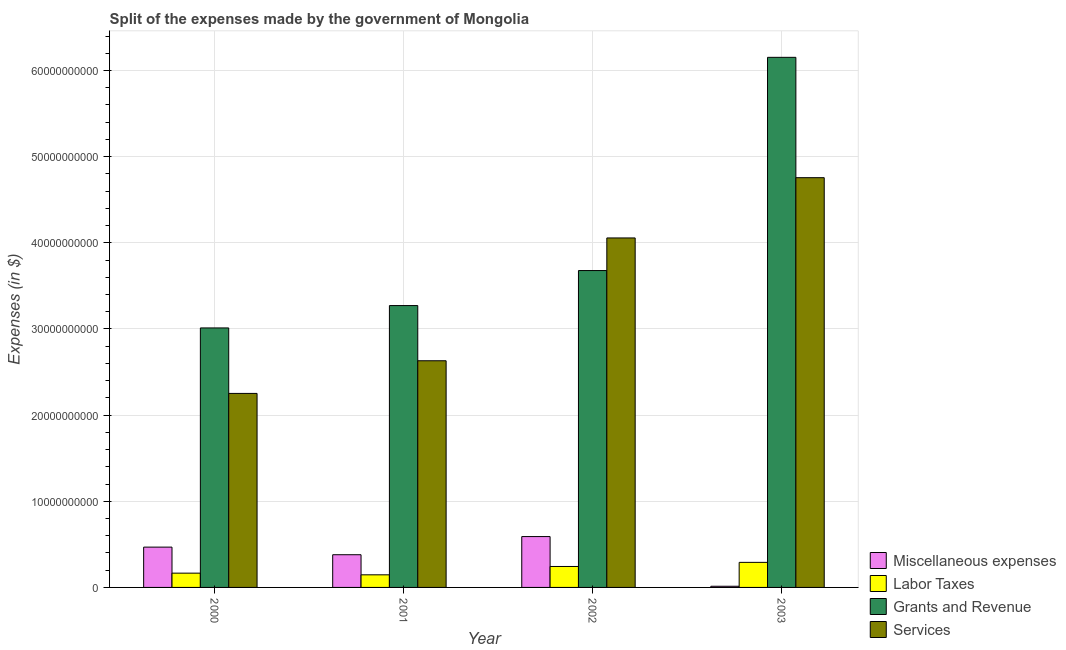How many groups of bars are there?
Your answer should be compact. 4. Are the number of bars per tick equal to the number of legend labels?
Offer a very short reply. Yes. Are the number of bars on each tick of the X-axis equal?
Ensure brevity in your answer.  Yes. What is the label of the 3rd group of bars from the left?
Make the answer very short. 2002. What is the amount spent on labor taxes in 2000?
Your response must be concise. 1.66e+09. Across all years, what is the maximum amount spent on services?
Give a very brief answer. 4.76e+1. Across all years, what is the minimum amount spent on grants and revenue?
Ensure brevity in your answer.  3.01e+1. What is the total amount spent on labor taxes in the graph?
Ensure brevity in your answer.  8.46e+09. What is the difference between the amount spent on miscellaneous expenses in 2000 and that in 2001?
Your response must be concise. 8.82e+08. What is the difference between the amount spent on grants and revenue in 2003 and the amount spent on miscellaneous expenses in 2001?
Offer a terse response. 2.88e+1. What is the average amount spent on grants and revenue per year?
Your answer should be compact. 4.03e+1. What is the ratio of the amount spent on services in 2001 to that in 2003?
Your answer should be compact. 0.55. Is the amount spent on miscellaneous expenses in 2001 less than that in 2002?
Your response must be concise. Yes. Is the difference between the amount spent on labor taxes in 2000 and 2001 greater than the difference between the amount spent on grants and revenue in 2000 and 2001?
Your answer should be very brief. No. What is the difference between the highest and the second highest amount spent on miscellaneous expenses?
Offer a very short reply. 1.22e+09. What is the difference between the highest and the lowest amount spent on miscellaneous expenses?
Offer a very short reply. 5.77e+09. Is the sum of the amount spent on grants and revenue in 2001 and 2003 greater than the maximum amount spent on miscellaneous expenses across all years?
Your response must be concise. Yes. What does the 2nd bar from the left in 2000 represents?
Provide a succinct answer. Labor Taxes. What does the 4th bar from the right in 2002 represents?
Your answer should be compact. Miscellaneous expenses. How many years are there in the graph?
Give a very brief answer. 4. What is the difference between two consecutive major ticks on the Y-axis?
Give a very brief answer. 1.00e+1. Are the values on the major ticks of Y-axis written in scientific E-notation?
Your answer should be very brief. No. Does the graph contain any zero values?
Your answer should be compact. No. Where does the legend appear in the graph?
Your response must be concise. Bottom right. How are the legend labels stacked?
Ensure brevity in your answer.  Vertical. What is the title of the graph?
Your response must be concise. Split of the expenses made by the government of Mongolia. Does "UNDP" appear as one of the legend labels in the graph?
Your answer should be very brief. No. What is the label or title of the X-axis?
Provide a succinct answer. Year. What is the label or title of the Y-axis?
Give a very brief answer. Expenses (in $). What is the Expenses (in $) in Miscellaneous expenses in 2000?
Your response must be concise. 4.68e+09. What is the Expenses (in $) in Labor Taxes in 2000?
Your answer should be compact. 1.66e+09. What is the Expenses (in $) of Grants and Revenue in 2000?
Your answer should be compact. 3.01e+1. What is the Expenses (in $) in Services in 2000?
Provide a short and direct response. 2.25e+1. What is the Expenses (in $) in Miscellaneous expenses in 2001?
Offer a very short reply. 3.80e+09. What is the Expenses (in $) in Labor Taxes in 2001?
Offer a very short reply. 1.46e+09. What is the Expenses (in $) in Grants and Revenue in 2001?
Offer a terse response. 3.27e+1. What is the Expenses (in $) in Services in 2001?
Make the answer very short. 2.63e+1. What is the Expenses (in $) of Miscellaneous expenses in 2002?
Keep it short and to the point. 5.90e+09. What is the Expenses (in $) in Labor Taxes in 2002?
Ensure brevity in your answer.  2.43e+09. What is the Expenses (in $) of Grants and Revenue in 2002?
Your answer should be compact. 3.68e+1. What is the Expenses (in $) of Services in 2002?
Offer a very short reply. 4.06e+1. What is the Expenses (in $) in Miscellaneous expenses in 2003?
Provide a succinct answer. 1.35e+08. What is the Expenses (in $) in Labor Taxes in 2003?
Your response must be concise. 2.91e+09. What is the Expenses (in $) of Grants and Revenue in 2003?
Your response must be concise. 6.15e+1. What is the Expenses (in $) of Services in 2003?
Make the answer very short. 4.76e+1. Across all years, what is the maximum Expenses (in $) in Miscellaneous expenses?
Ensure brevity in your answer.  5.90e+09. Across all years, what is the maximum Expenses (in $) of Labor Taxes?
Offer a very short reply. 2.91e+09. Across all years, what is the maximum Expenses (in $) in Grants and Revenue?
Offer a terse response. 6.15e+1. Across all years, what is the maximum Expenses (in $) of Services?
Provide a short and direct response. 4.76e+1. Across all years, what is the minimum Expenses (in $) of Miscellaneous expenses?
Ensure brevity in your answer.  1.35e+08. Across all years, what is the minimum Expenses (in $) of Labor Taxes?
Provide a succinct answer. 1.46e+09. Across all years, what is the minimum Expenses (in $) in Grants and Revenue?
Your answer should be compact. 3.01e+1. Across all years, what is the minimum Expenses (in $) of Services?
Ensure brevity in your answer.  2.25e+1. What is the total Expenses (in $) in Miscellaneous expenses in the graph?
Your answer should be very brief. 1.45e+1. What is the total Expenses (in $) of Labor Taxes in the graph?
Ensure brevity in your answer.  8.46e+09. What is the total Expenses (in $) of Grants and Revenue in the graph?
Offer a terse response. 1.61e+11. What is the total Expenses (in $) of Services in the graph?
Your answer should be compact. 1.37e+11. What is the difference between the Expenses (in $) in Miscellaneous expenses in 2000 and that in 2001?
Offer a terse response. 8.82e+08. What is the difference between the Expenses (in $) of Labor Taxes in 2000 and that in 2001?
Provide a short and direct response. 1.94e+08. What is the difference between the Expenses (in $) of Grants and Revenue in 2000 and that in 2001?
Keep it short and to the point. -2.60e+09. What is the difference between the Expenses (in $) in Services in 2000 and that in 2001?
Provide a succinct answer. -3.79e+09. What is the difference between the Expenses (in $) in Miscellaneous expenses in 2000 and that in 2002?
Provide a succinct answer. -1.22e+09. What is the difference between the Expenses (in $) of Labor Taxes in 2000 and that in 2002?
Your answer should be very brief. -7.74e+08. What is the difference between the Expenses (in $) in Grants and Revenue in 2000 and that in 2002?
Keep it short and to the point. -6.66e+09. What is the difference between the Expenses (in $) in Services in 2000 and that in 2002?
Give a very brief answer. -1.80e+1. What is the difference between the Expenses (in $) in Miscellaneous expenses in 2000 and that in 2003?
Provide a short and direct response. 4.54e+09. What is the difference between the Expenses (in $) in Labor Taxes in 2000 and that in 2003?
Offer a terse response. -1.25e+09. What is the difference between the Expenses (in $) in Grants and Revenue in 2000 and that in 2003?
Your answer should be compact. -3.14e+1. What is the difference between the Expenses (in $) of Services in 2000 and that in 2003?
Keep it short and to the point. -2.50e+1. What is the difference between the Expenses (in $) of Miscellaneous expenses in 2001 and that in 2002?
Offer a terse response. -2.11e+09. What is the difference between the Expenses (in $) of Labor Taxes in 2001 and that in 2002?
Offer a very short reply. -9.68e+08. What is the difference between the Expenses (in $) of Grants and Revenue in 2001 and that in 2002?
Your answer should be compact. -4.06e+09. What is the difference between the Expenses (in $) in Services in 2001 and that in 2002?
Your answer should be very brief. -1.43e+1. What is the difference between the Expenses (in $) in Miscellaneous expenses in 2001 and that in 2003?
Keep it short and to the point. 3.66e+09. What is the difference between the Expenses (in $) in Labor Taxes in 2001 and that in 2003?
Your answer should be compact. -1.44e+09. What is the difference between the Expenses (in $) in Grants and Revenue in 2001 and that in 2003?
Offer a terse response. -2.88e+1. What is the difference between the Expenses (in $) in Services in 2001 and that in 2003?
Offer a very short reply. -2.12e+1. What is the difference between the Expenses (in $) of Miscellaneous expenses in 2002 and that in 2003?
Offer a terse response. 5.77e+09. What is the difference between the Expenses (in $) in Labor Taxes in 2002 and that in 2003?
Offer a very short reply. -4.76e+08. What is the difference between the Expenses (in $) in Grants and Revenue in 2002 and that in 2003?
Your answer should be compact. -2.47e+1. What is the difference between the Expenses (in $) of Services in 2002 and that in 2003?
Ensure brevity in your answer.  -6.99e+09. What is the difference between the Expenses (in $) of Miscellaneous expenses in 2000 and the Expenses (in $) of Labor Taxes in 2001?
Keep it short and to the point. 3.21e+09. What is the difference between the Expenses (in $) in Miscellaneous expenses in 2000 and the Expenses (in $) in Grants and Revenue in 2001?
Give a very brief answer. -2.80e+1. What is the difference between the Expenses (in $) in Miscellaneous expenses in 2000 and the Expenses (in $) in Services in 2001?
Give a very brief answer. -2.16e+1. What is the difference between the Expenses (in $) of Labor Taxes in 2000 and the Expenses (in $) of Grants and Revenue in 2001?
Offer a terse response. -3.11e+1. What is the difference between the Expenses (in $) in Labor Taxes in 2000 and the Expenses (in $) in Services in 2001?
Ensure brevity in your answer.  -2.47e+1. What is the difference between the Expenses (in $) of Grants and Revenue in 2000 and the Expenses (in $) of Services in 2001?
Your answer should be compact. 3.81e+09. What is the difference between the Expenses (in $) of Miscellaneous expenses in 2000 and the Expenses (in $) of Labor Taxes in 2002?
Your answer should be very brief. 2.25e+09. What is the difference between the Expenses (in $) in Miscellaneous expenses in 2000 and the Expenses (in $) in Grants and Revenue in 2002?
Your answer should be compact. -3.21e+1. What is the difference between the Expenses (in $) in Miscellaneous expenses in 2000 and the Expenses (in $) in Services in 2002?
Ensure brevity in your answer.  -3.59e+1. What is the difference between the Expenses (in $) in Labor Taxes in 2000 and the Expenses (in $) in Grants and Revenue in 2002?
Give a very brief answer. -3.51e+1. What is the difference between the Expenses (in $) in Labor Taxes in 2000 and the Expenses (in $) in Services in 2002?
Your response must be concise. -3.89e+1. What is the difference between the Expenses (in $) in Grants and Revenue in 2000 and the Expenses (in $) in Services in 2002?
Offer a terse response. -1.04e+1. What is the difference between the Expenses (in $) of Miscellaneous expenses in 2000 and the Expenses (in $) of Labor Taxes in 2003?
Make the answer very short. 1.77e+09. What is the difference between the Expenses (in $) in Miscellaneous expenses in 2000 and the Expenses (in $) in Grants and Revenue in 2003?
Make the answer very short. -5.69e+1. What is the difference between the Expenses (in $) of Miscellaneous expenses in 2000 and the Expenses (in $) of Services in 2003?
Make the answer very short. -4.29e+1. What is the difference between the Expenses (in $) in Labor Taxes in 2000 and the Expenses (in $) in Grants and Revenue in 2003?
Offer a very short reply. -5.99e+1. What is the difference between the Expenses (in $) in Labor Taxes in 2000 and the Expenses (in $) in Services in 2003?
Your answer should be very brief. -4.59e+1. What is the difference between the Expenses (in $) of Grants and Revenue in 2000 and the Expenses (in $) of Services in 2003?
Keep it short and to the point. -1.74e+1. What is the difference between the Expenses (in $) in Miscellaneous expenses in 2001 and the Expenses (in $) in Labor Taxes in 2002?
Offer a very short reply. 1.36e+09. What is the difference between the Expenses (in $) in Miscellaneous expenses in 2001 and the Expenses (in $) in Grants and Revenue in 2002?
Provide a succinct answer. -3.30e+1. What is the difference between the Expenses (in $) in Miscellaneous expenses in 2001 and the Expenses (in $) in Services in 2002?
Your answer should be very brief. -3.68e+1. What is the difference between the Expenses (in $) of Labor Taxes in 2001 and the Expenses (in $) of Grants and Revenue in 2002?
Your answer should be very brief. -3.53e+1. What is the difference between the Expenses (in $) of Labor Taxes in 2001 and the Expenses (in $) of Services in 2002?
Offer a very short reply. -3.91e+1. What is the difference between the Expenses (in $) in Grants and Revenue in 2001 and the Expenses (in $) in Services in 2002?
Your response must be concise. -7.85e+09. What is the difference between the Expenses (in $) in Miscellaneous expenses in 2001 and the Expenses (in $) in Labor Taxes in 2003?
Give a very brief answer. 8.88e+08. What is the difference between the Expenses (in $) of Miscellaneous expenses in 2001 and the Expenses (in $) of Grants and Revenue in 2003?
Your answer should be compact. -5.77e+1. What is the difference between the Expenses (in $) in Miscellaneous expenses in 2001 and the Expenses (in $) in Services in 2003?
Offer a very short reply. -4.38e+1. What is the difference between the Expenses (in $) of Labor Taxes in 2001 and the Expenses (in $) of Grants and Revenue in 2003?
Give a very brief answer. -6.01e+1. What is the difference between the Expenses (in $) in Labor Taxes in 2001 and the Expenses (in $) in Services in 2003?
Provide a succinct answer. -4.61e+1. What is the difference between the Expenses (in $) in Grants and Revenue in 2001 and the Expenses (in $) in Services in 2003?
Your answer should be very brief. -1.48e+1. What is the difference between the Expenses (in $) in Miscellaneous expenses in 2002 and the Expenses (in $) in Labor Taxes in 2003?
Provide a succinct answer. 2.99e+09. What is the difference between the Expenses (in $) of Miscellaneous expenses in 2002 and the Expenses (in $) of Grants and Revenue in 2003?
Make the answer very short. -5.56e+1. What is the difference between the Expenses (in $) of Miscellaneous expenses in 2002 and the Expenses (in $) of Services in 2003?
Your answer should be very brief. -4.17e+1. What is the difference between the Expenses (in $) in Labor Taxes in 2002 and the Expenses (in $) in Grants and Revenue in 2003?
Offer a terse response. -5.91e+1. What is the difference between the Expenses (in $) of Labor Taxes in 2002 and the Expenses (in $) of Services in 2003?
Offer a very short reply. -4.51e+1. What is the difference between the Expenses (in $) in Grants and Revenue in 2002 and the Expenses (in $) in Services in 2003?
Offer a very short reply. -1.08e+1. What is the average Expenses (in $) in Miscellaneous expenses per year?
Your answer should be compact. 3.63e+09. What is the average Expenses (in $) of Labor Taxes per year?
Keep it short and to the point. 2.12e+09. What is the average Expenses (in $) of Grants and Revenue per year?
Your answer should be compact. 4.03e+1. What is the average Expenses (in $) in Services per year?
Your answer should be very brief. 3.42e+1. In the year 2000, what is the difference between the Expenses (in $) of Miscellaneous expenses and Expenses (in $) of Labor Taxes?
Your answer should be compact. 3.02e+09. In the year 2000, what is the difference between the Expenses (in $) in Miscellaneous expenses and Expenses (in $) in Grants and Revenue?
Give a very brief answer. -2.54e+1. In the year 2000, what is the difference between the Expenses (in $) in Miscellaneous expenses and Expenses (in $) in Services?
Provide a short and direct response. -1.78e+1. In the year 2000, what is the difference between the Expenses (in $) of Labor Taxes and Expenses (in $) of Grants and Revenue?
Your answer should be very brief. -2.85e+1. In the year 2000, what is the difference between the Expenses (in $) of Labor Taxes and Expenses (in $) of Services?
Offer a very short reply. -2.09e+1. In the year 2000, what is the difference between the Expenses (in $) of Grants and Revenue and Expenses (in $) of Services?
Offer a terse response. 7.60e+09. In the year 2001, what is the difference between the Expenses (in $) in Miscellaneous expenses and Expenses (in $) in Labor Taxes?
Your answer should be compact. 2.33e+09. In the year 2001, what is the difference between the Expenses (in $) of Miscellaneous expenses and Expenses (in $) of Grants and Revenue?
Your answer should be compact. -2.89e+1. In the year 2001, what is the difference between the Expenses (in $) in Miscellaneous expenses and Expenses (in $) in Services?
Your answer should be very brief. -2.25e+1. In the year 2001, what is the difference between the Expenses (in $) in Labor Taxes and Expenses (in $) in Grants and Revenue?
Your response must be concise. -3.13e+1. In the year 2001, what is the difference between the Expenses (in $) in Labor Taxes and Expenses (in $) in Services?
Provide a succinct answer. -2.48e+1. In the year 2001, what is the difference between the Expenses (in $) of Grants and Revenue and Expenses (in $) of Services?
Your response must be concise. 6.41e+09. In the year 2002, what is the difference between the Expenses (in $) of Miscellaneous expenses and Expenses (in $) of Labor Taxes?
Keep it short and to the point. 3.47e+09. In the year 2002, what is the difference between the Expenses (in $) of Miscellaneous expenses and Expenses (in $) of Grants and Revenue?
Offer a terse response. -3.09e+1. In the year 2002, what is the difference between the Expenses (in $) in Miscellaneous expenses and Expenses (in $) in Services?
Provide a succinct answer. -3.47e+1. In the year 2002, what is the difference between the Expenses (in $) of Labor Taxes and Expenses (in $) of Grants and Revenue?
Give a very brief answer. -3.43e+1. In the year 2002, what is the difference between the Expenses (in $) of Labor Taxes and Expenses (in $) of Services?
Offer a terse response. -3.81e+1. In the year 2002, what is the difference between the Expenses (in $) of Grants and Revenue and Expenses (in $) of Services?
Offer a terse response. -3.78e+09. In the year 2003, what is the difference between the Expenses (in $) in Miscellaneous expenses and Expenses (in $) in Labor Taxes?
Your answer should be very brief. -2.77e+09. In the year 2003, what is the difference between the Expenses (in $) of Miscellaneous expenses and Expenses (in $) of Grants and Revenue?
Provide a short and direct response. -6.14e+1. In the year 2003, what is the difference between the Expenses (in $) of Miscellaneous expenses and Expenses (in $) of Services?
Keep it short and to the point. -4.74e+1. In the year 2003, what is the difference between the Expenses (in $) of Labor Taxes and Expenses (in $) of Grants and Revenue?
Offer a very short reply. -5.86e+1. In the year 2003, what is the difference between the Expenses (in $) in Labor Taxes and Expenses (in $) in Services?
Your answer should be compact. -4.47e+1. In the year 2003, what is the difference between the Expenses (in $) in Grants and Revenue and Expenses (in $) in Services?
Make the answer very short. 1.40e+1. What is the ratio of the Expenses (in $) in Miscellaneous expenses in 2000 to that in 2001?
Give a very brief answer. 1.23. What is the ratio of the Expenses (in $) in Labor Taxes in 2000 to that in 2001?
Offer a terse response. 1.13. What is the ratio of the Expenses (in $) of Grants and Revenue in 2000 to that in 2001?
Provide a succinct answer. 0.92. What is the ratio of the Expenses (in $) of Services in 2000 to that in 2001?
Your response must be concise. 0.86. What is the ratio of the Expenses (in $) in Miscellaneous expenses in 2000 to that in 2002?
Your response must be concise. 0.79. What is the ratio of the Expenses (in $) in Labor Taxes in 2000 to that in 2002?
Keep it short and to the point. 0.68. What is the ratio of the Expenses (in $) in Grants and Revenue in 2000 to that in 2002?
Ensure brevity in your answer.  0.82. What is the ratio of the Expenses (in $) in Services in 2000 to that in 2002?
Provide a short and direct response. 0.56. What is the ratio of the Expenses (in $) of Miscellaneous expenses in 2000 to that in 2003?
Make the answer very short. 34.67. What is the ratio of the Expenses (in $) in Labor Taxes in 2000 to that in 2003?
Your response must be concise. 0.57. What is the ratio of the Expenses (in $) in Grants and Revenue in 2000 to that in 2003?
Provide a short and direct response. 0.49. What is the ratio of the Expenses (in $) in Services in 2000 to that in 2003?
Ensure brevity in your answer.  0.47. What is the ratio of the Expenses (in $) of Miscellaneous expenses in 2001 to that in 2002?
Keep it short and to the point. 0.64. What is the ratio of the Expenses (in $) of Labor Taxes in 2001 to that in 2002?
Give a very brief answer. 0.6. What is the ratio of the Expenses (in $) of Grants and Revenue in 2001 to that in 2002?
Your answer should be very brief. 0.89. What is the ratio of the Expenses (in $) of Services in 2001 to that in 2002?
Your response must be concise. 0.65. What is the ratio of the Expenses (in $) in Miscellaneous expenses in 2001 to that in 2003?
Provide a succinct answer. 28.13. What is the ratio of the Expenses (in $) in Labor Taxes in 2001 to that in 2003?
Your answer should be compact. 0.5. What is the ratio of the Expenses (in $) of Grants and Revenue in 2001 to that in 2003?
Your response must be concise. 0.53. What is the ratio of the Expenses (in $) of Services in 2001 to that in 2003?
Offer a very short reply. 0.55. What is the ratio of the Expenses (in $) in Miscellaneous expenses in 2002 to that in 2003?
Your answer should be very brief. 43.74. What is the ratio of the Expenses (in $) in Labor Taxes in 2002 to that in 2003?
Give a very brief answer. 0.84. What is the ratio of the Expenses (in $) in Grants and Revenue in 2002 to that in 2003?
Provide a short and direct response. 0.6. What is the ratio of the Expenses (in $) of Services in 2002 to that in 2003?
Make the answer very short. 0.85. What is the difference between the highest and the second highest Expenses (in $) in Miscellaneous expenses?
Keep it short and to the point. 1.22e+09. What is the difference between the highest and the second highest Expenses (in $) in Labor Taxes?
Give a very brief answer. 4.76e+08. What is the difference between the highest and the second highest Expenses (in $) of Grants and Revenue?
Ensure brevity in your answer.  2.47e+1. What is the difference between the highest and the second highest Expenses (in $) in Services?
Make the answer very short. 6.99e+09. What is the difference between the highest and the lowest Expenses (in $) in Miscellaneous expenses?
Provide a succinct answer. 5.77e+09. What is the difference between the highest and the lowest Expenses (in $) of Labor Taxes?
Your answer should be compact. 1.44e+09. What is the difference between the highest and the lowest Expenses (in $) in Grants and Revenue?
Give a very brief answer. 3.14e+1. What is the difference between the highest and the lowest Expenses (in $) in Services?
Your answer should be very brief. 2.50e+1. 